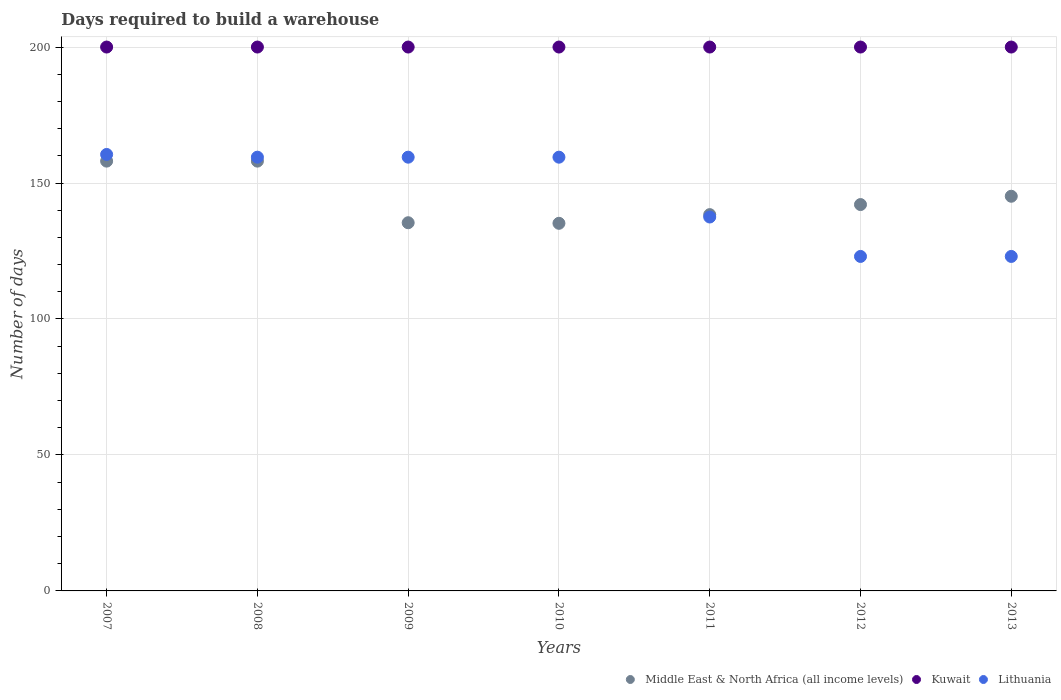How many different coloured dotlines are there?
Your answer should be compact. 3. Is the number of dotlines equal to the number of legend labels?
Provide a short and direct response. Yes. What is the days required to build a warehouse in in Kuwait in 2007?
Offer a terse response. 200. Across all years, what is the maximum days required to build a warehouse in in Lithuania?
Offer a very short reply. 160.5. Across all years, what is the minimum days required to build a warehouse in in Middle East & North Africa (all income levels)?
Provide a succinct answer. 135.18. In which year was the days required to build a warehouse in in Lithuania minimum?
Make the answer very short. 2012. What is the total days required to build a warehouse in in Lithuania in the graph?
Offer a terse response. 1022.5. What is the difference between the days required to build a warehouse in in Middle East & North Africa (all income levels) in 2007 and that in 2010?
Offer a terse response. 22.87. What is the difference between the days required to build a warehouse in in Middle East & North Africa (all income levels) in 2010 and the days required to build a warehouse in in Kuwait in 2009?
Your answer should be very brief. -64.82. What is the average days required to build a warehouse in in Lithuania per year?
Give a very brief answer. 146.07. In the year 2008, what is the difference between the days required to build a warehouse in in Kuwait and days required to build a warehouse in in Lithuania?
Ensure brevity in your answer.  40.5. In how many years, is the days required to build a warehouse in in Lithuania greater than 90 days?
Offer a terse response. 7. What is the ratio of the days required to build a warehouse in in Middle East & North Africa (all income levels) in 2008 to that in 2012?
Provide a succinct answer. 1.11. Is the days required to build a warehouse in in Kuwait in 2007 less than that in 2013?
Provide a succinct answer. No. Is the difference between the days required to build a warehouse in in Kuwait in 2010 and 2012 greater than the difference between the days required to build a warehouse in in Lithuania in 2010 and 2012?
Provide a succinct answer. No. What is the difference between the highest and the lowest days required to build a warehouse in in Lithuania?
Your answer should be compact. 37.5. In how many years, is the days required to build a warehouse in in Middle East & North Africa (all income levels) greater than the average days required to build a warehouse in in Middle East & North Africa (all income levels) taken over all years?
Your answer should be compact. 3. Is the sum of the days required to build a warehouse in in Kuwait in 2009 and 2013 greater than the maximum days required to build a warehouse in in Lithuania across all years?
Make the answer very short. Yes. Is it the case that in every year, the sum of the days required to build a warehouse in in Kuwait and days required to build a warehouse in in Middle East & North Africa (all income levels)  is greater than the days required to build a warehouse in in Lithuania?
Your answer should be compact. Yes. Does the days required to build a warehouse in in Kuwait monotonically increase over the years?
Offer a very short reply. No. Is the days required to build a warehouse in in Kuwait strictly greater than the days required to build a warehouse in in Lithuania over the years?
Provide a short and direct response. Yes. How many dotlines are there?
Ensure brevity in your answer.  3. What is the difference between two consecutive major ticks on the Y-axis?
Offer a very short reply. 50. Are the values on the major ticks of Y-axis written in scientific E-notation?
Make the answer very short. No. Does the graph contain grids?
Offer a very short reply. Yes. What is the title of the graph?
Make the answer very short. Days required to build a warehouse. What is the label or title of the X-axis?
Your answer should be compact. Years. What is the label or title of the Y-axis?
Your answer should be compact. Number of days. What is the Number of days of Middle East & North Africa (all income levels) in 2007?
Your response must be concise. 158.05. What is the Number of days of Kuwait in 2007?
Offer a terse response. 200. What is the Number of days in Lithuania in 2007?
Ensure brevity in your answer.  160.5. What is the Number of days of Middle East & North Africa (all income levels) in 2008?
Your response must be concise. 158.05. What is the Number of days of Kuwait in 2008?
Give a very brief answer. 200. What is the Number of days of Lithuania in 2008?
Offer a very short reply. 159.5. What is the Number of days of Middle East & North Africa (all income levels) in 2009?
Provide a succinct answer. 135.39. What is the Number of days of Lithuania in 2009?
Ensure brevity in your answer.  159.5. What is the Number of days of Middle East & North Africa (all income levels) in 2010?
Your response must be concise. 135.18. What is the Number of days in Lithuania in 2010?
Provide a short and direct response. 159.5. What is the Number of days in Middle East & North Africa (all income levels) in 2011?
Your answer should be compact. 138.38. What is the Number of days of Lithuania in 2011?
Offer a terse response. 137.5. What is the Number of days of Middle East & North Africa (all income levels) in 2012?
Your answer should be very brief. 142.07. What is the Number of days in Kuwait in 2012?
Offer a very short reply. 200. What is the Number of days of Lithuania in 2012?
Your response must be concise. 123. What is the Number of days in Middle East & North Africa (all income levels) in 2013?
Ensure brevity in your answer.  145.13. What is the Number of days of Lithuania in 2013?
Offer a terse response. 123. Across all years, what is the maximum Number of days in Middle East & North Africa (all income levels)?
Your answer should be compact. 158.05. Across all years, what is the maximum Number of days of Lithuania?
Your answer should be compact. 160.5. Across all years, what is the minimum Number of days of Middle East & North Africa (all income levels)?
Give a very brief answer. 135.18. Across all years, what is the minimum Number of days of Kuwait?
Provide a short and direct response. 200. Across all years, what is the minimum Number of days of Lithuania?
Your answer should be very brief. 123. What is the total Number of days in Middle East & North Africa (all income levels) in the graph?
Your response must be concise. 1012.27. What is the total Number of days in Kuwait in the graph?
Offer a terse response. 1400. What is the total Number of days in Lithuania in the graph?
Provide a short and direct response. 1022.5. What is the difference between the Number of days of Kuwait in 2007 and that in 2008?
Provide a short and direct response. 0. What is the difference between the Number of days of Middle East & North Africa (all income levels) in 2007 and that in 2009?
Your answer should be very brief. 22.66. What is the difference between the Number of days of Kuwait in 2007 and that in 2009?
Provide a succinct answer. 0. What is the difference between the Number of days of Lithuania in 2007 and that in 2009?
Keep it short and to the point. 1. What is the difference between the Number of days of Middle East & North Africa (all income levels) in 2007 and that in 2010?
Your answer should be compact. 22.87. What is the difference between the Number of days of Kuwait in 2007 and that in 2010?
Ensure brevity in your answer.  0. What is the difference between the Number of days in Lithuania in 2007 and that in 2010?
Your response must be concise. 1. What is the difference between the Number of days in Middle East & North Africa (all income levels) in 2007 and that in 2011?
Provide a short and direct response. 19.68. What is the difference between the Number of days of Kuwait in 2007 and that in 2011?
Your response must be concise. 0. What is the difference between the Number of days in Lithuania in 2007 and that in 2011?
Make the answer very short. 23. What is the difference between the Number of days in Middle East & North Africa (all income levels) in 2007 and that in 2012?
Ensure brevity in your answer.  15.98. What is the difference between the Number of days of Kuwait in 2007 and that in 2012?
Give a very brief answer. 0. What is the difference between the Number of days in Lithuania in 2007 and that in 2012?
Your answer should be very brief. 37.5. What is the difference between the Number of days in Middle East & North Africa (all income levels) in 2007 and that in 2013?
Your response must be concise. 12.92. What is the difference between the Number of days in Kuwait in 2007 and that in 2013?
Your response must be concise. 0. What is the difference between the Number of days in Lithuania in 2007 and that in 2013?
Keep it short and to the point. 37.5. What is the difference between the Number of days of Middle East & North Africa (all income levels) in 2008 and that in 2009?
Keep it short and to the point. 22.66. What is the difference between the Number of days in Kuwait in 2008 and that in 2009?
Your response must be concise. 0. What is the difference between the Number of days of Middle East & North Africa (all income levels) in 2008 and that in 2010?
Your answer should be compact. 22.87. What is the difference between the Number of days of Lithuania in 2008 and that in 2010?
Offer a very short reply. 0. What is the difference between the Number of days of Middle East & North Africa (all income levels) in 2008 and that in 2011?
Provide a succinct answer. 19.68. What is the difference between the Number of days in Middle East & North Africa (all income levels) in 2008 and that in 2012?
Keep it short and to the point. 15.98. What is the difference between the Number of days of Kuwait in 2008 and that in 2012?
Give a very brief answer. 0. What is the difference between the Number of days in Lithuania in 2008 and that in 2012?
Provide a succinct answer. 36.5. What is the difference between the Number of days in Middle East & North Africa (all income levels) in 2008 and that in 2013?
Ensure brevity in your answer.  12.92. What is the difference between the Number of days of Kuwait in 2008 and that in 2013?
Provide a succinct answer. 0. What is the difference between the Number of days of Lithuania in 2008 and that in 2013?
Offer a terse response. 36.5. What is the difference between the Number of days in Middle East & North Africa (all income levels) in 2009 and that in 2010?
Provide a short and direct response. 0.21. What is the difference between the Number of days in Kuwait in 2009 and that in 2010?
Make the answer very short. 0. What is the difference between the Number of days of Middle East & North Africa (all income levels) in 2009 and that in 2011?
Offer a terse response. -2.98. What is the difference between the Number of days in Kuwait in 2009 and that in 2011?
Your answer should be very brief. 0. What is the difference between the Number of days of Middle East & North Africa (all income levels) in 2009 and that in 2012?
Provide a short and direct response. -6.68. What is the difference between the Number of days in Kuwait in 2009 and that in 2012?
Your answer should be very brief. 0. What is the difference between the Number of days in Lithuania in 2009 and that in 2012?
Your answer should be very brief. 36.5. What is the difference between the Number of days of Middle East & North Africa (all income levels) in 2009 and that in 2013?
Provide a succinct answer. -9.74. What is the difference between the Number of days of Kuwait in 2009 and that in 2013?
Your answer should be compact. 0. What is the difference between the Number of days in Lithuania in 2009 and that in 2013?
Your answer should be compact. 36.5. What is the difference between the Number of days in Middle East & North Africa (all income levels) in 2010 and that in 2011?
Keep it short and to the point. -3.19. What is the difference between the Number of days of Lithuania in 2010 and that in 2011?
Give a very brief answer. 22. What is the difference between the Number of days in Middle East & North Africa (all income levels) in 2010 and that in 2012?
Make the answer very short. -6.89. What is the difference between the Number of days of Lithuania in 2010 and that in 2012?
Make the answer very short. 36.5. What is the difference between the Number of days in Middle East & North Africa (all income levels) in 2010 and that in 2013?
Your response must be concise. -9.95. What is the difference between the Number of days of Lithuania in 2010 and that in 2013?
Make the answer very short. 36.5. What is the difference between the Number of days of Middle East & North Africa (all income levels) in 2011 and that in 2012?
Provide a short and direct response. -3.7. What is the difference between the Number of days of Kuwait in 2011 and that in 2012?
Offer a terse response. 0. What is the difference between the Number of days in Middle East & North Africa (all income levels) in 2011 and that in 2013?
Offer a very short reply. -6.76. What is the difference between the Number of days in Lithuania in 2011 and that in 2013?
Offer a very short reply. 14.5. What is the difference between the Number of days of Middle East & North Africa (all income levels) in 2012 and that in 2013?
Make the answer very short. -3.06. What is the difference between the Number of days in Kuwait in 2012 and that in 2013?
Your response must be concise. 0. What is the difference between the Number of days of Lithuania in 2012 and that in 2013?
Provide a succinct answer. 0. What is the difference between the Number of days in Middle East & North Africa (all income levels) in 2007 and the Number of days in Kuwait in 2008?
Your answer should be very brief. -41.95. What is the difference between the Number of days in Middle East & North Africa (all income levels) in 2007 and the Number of days in Lithuania in 2008?
Your answer should be very brief. -1.45. What is the difference between the Number of days of Kuwait in 2007 and the Number of days of Lithuania in 2008?
Give a very brief answer. 40.5. What is the difference between the Number of days in Middle East & North Africa (all income levels) in 2007 and the Number of days in Kuwait in 2009?
Your response must be concise. -41.95. What is the difference between the Number of days of Middle East & North Africa (all income levels) in 2007 and the Number of days of Lithuania in 2009?
Your answer should be compact. -1.45. What is the difference between the Number of days of Kuwait in 2007 and the Number of days of Lithuania in 2009?
Ensure brevity in your answer.  40.5. What is the difference between the Number of days of Middle East & North Africa (all income levels) in 2007 and the Number of days of Kuwait in 2010?
Provide a succinct answer. -41.95. What is the difference between the Number of days of Middle East & North Africa (all income levels) in 2007 and the Number of days of Lithuania in 2010?
Your answer should be very brief. -1.45. What is the difference between the Number of days of Kuwait in 2007 and the Number of days of Lithuania in 2010?
Provide a succinct answer. 40.5. What is the difference between the Number of days of Middle East & North Africa (all income levels) in 2007 and the Number of days of Kuwait in 2011?
Provide a short and direct response. -41.95. What is the difference between the Number of days in Middle East & North Africa (all income levels) in 2007 and the Number of days in Lithuania in 2011?
Offer a very short reply. 20.55. What is the difference between the Number of days in Kuwait in 2007 and the Number of days in Lithuania in 2011?
Offer a terse response. 62.5. What is the difference between the Number of days in Middle East & North Africa (all income levels) in 2007 and the Number of days in Kuwait in 2012?
Your response must be concise. -41.95. What is the difference between the Number of days of Middle East & North Africa (all income levels) in 2007 and the Number of days of Lithuania in 2012?
Your answer should be very brief. 35.05. What is the difference between the Number of days in Middle East & North Africa (all income levels) in 2007 and the Number of days in Kuwait in 2013?
Offer a terse response. -41.95. What is the difference between the Number of days in Middle East & North Africa (all income levels) in 2007 and the Number of days in Lithuania in 2013?
Give a very brief answer. 35.05. What is the difference between the Number of days of Middle East & North Africa (all income levels) in 2008 and the Number of days of Kuwait in 2009?
Provide a short and direct response. -41.95. What is the difference between the Number of days of Middle East & North Africa (all income levels) in 2008 and the Number of days of Lithuania in 2009?
Make the answer very short. -1.45. What is the difference between the Number of days of Kuwait in 2008 and the Number of days of Lithuania in 2009?
Offer a terse response. 40.5. What is the difference between the Number of days in Middle East & North Africa (all income levels) in 2008 and the Number of days in Kuwait in 2010?
Offer a terse response. -41.95. What is the difference between the Number of days in Middle East & North Africa (all income levels) in 2008 and the Number of days in Lithuania in 2010?
Your answer should be compact. -1.45. What is the difference between the Number of days of Kuwait in 2008 and the Number of days of Lithuania in 2010?
Your answer should be very brief. 40.5. What is the difference between the Number of days in Middle East & North Africa (all income levels) in 2008 and the Number of days in Kuwait in 2011?
Give a very brief answer. -41.95. What is the difference between the Number of days of Middle East & North Africa (all income levels) in 2008 and the Number of days of Lithuania in 2011?
Keep it short and to the point. 20.55. What is the difference between the Number of days in Kuwait in 2008 and the Number of days in Lithuania in 2011?
Offer a very short reply. 62.5. What is the difference between the Number of days of Middle East & North Africa (all income levels) in 2008 and the Number of days of Kuwait in 2012?
Make the answer very short. -41.95. What is the difference between the Number of days in Middle East & North Africa (all income levels) in 2008 and the Number of days in Lithuania in 2012?
Ensure brevity in your answer.  35.05. What is the difference between the Number of days in Middle East & North Africa (all income levels) in 2008 and the Number of days in Kuwait in 2013?
Your answer should be compact. -41.95. What is the difference between the Number of days of Middle East & North Africa (all income levels) in 2008 and the Number of days of Lithuania in 2013?
Offer a terse response. 35.05. What is the difference between the Number of days in Middle East & North Africa (all income levels) in 2009 and the Number of days in Kuwait in 2010?
Offer a very short reply. -64.61. What is the difference between the Number of days in Middle East & North Africa (all income levels) in 2009 and the Number of days in Lithuania in 2010?
Your response must be concise. -24.11. What is the difference between the Number of days of Kuwait in 2009 and the Number of days of Lithuania in 2010?
Give a very brief answer. 40.5. What is the difference between the Number of days of Middle East & North Africa (all income levels) in 2009 and the Number of days of Kuwait in 2011?
Keep it short and to the point. -64.61. What is the difference between the Number of days in Middle East & North Africa (all income levels) in 2009 and the Number of days in Lithuania in 2011?
Your response must be concise. -2.11. What is the difference between the Number of days of Kuwait in 2009 and the Number of days of Lithuania in 2011?
Offer a terse response. 62.5. What is the difference between the Number of days in Middle East & North Africa (all income levels) in 2009 and the Number of days in Kuwait in 2012?
Your answer should be very brief. -64.61. What is the difference between the Number of days in Middle East & North Africa (all income levels) in 2009 and the Number of days in Lithuania in 2012?
Offer a terse response. 12.39. What is the difference between the Number of days in Kuwait in 2009 and the Number of days in Lithuania in 2012?
Your answer should be very brief. 77. What is the difference between the Number of days of Middle East & North Africa (all income levels) in 2009 and the Number of days of Kuwait in 2013?
Make the answer very short. -64.61. What is the difference between the Number of days in Middle East & North Africa (all income levels) in 2009 and the Number of days in Lithuania in 2013?
Give a very brief answer. 12.39. What is the difference between the Number of days of Kuwait in 2009 and the Number of days of Lithuania in 2013?
Ensure brevity in your answer.  77. What is the difference between the Number of days in Middle East & North Africa (all income levels) in 2010 and the Number of days in Kuwait in 2011?
Offer a very short reply. -64.82. What is the difference between the Number of days of Middle East & North Africa (all income levels) in 2010 and the Number of days of Lithuania in 2011?
Your answer should be very brief. -2.32. What is the difference between the Number of days of Kuwait in 2010 and the Number of days of Lithuania in 2011?
Your answer should be compact. 62.5. What is the difference between the Number of days of Middle East & North Africa (all income levels) in 2010 and the Number of days of Kuwait in 2012?
Make the answer very short. -64.82. What is the difference between the Number of days in Middle East & North Africa (all income levels) in 2010 and the Number of days in Lithuania in 2012?
Give a very brief answer. 12.18. What is the difference between the Number of days in Kuwait in 2010 and the Number of days in Lithuania in 2012?
Provide a succinct answer. 77. What is the difference between the Number of days in Middle East & North Africa (all income levels) in 2010 and the Number of days in Kuwait in 2013?
Ensure brevity in your answer.  -64.82. What is the difference between the Number of days in Middle East & North Africa (all income levels) in 2010 and the Number of days in Lithuania in 2013?
Offer a terse response. 12.18. What is the difference between the Number of days of Middle East & North Africa (all income levels) in 2011 and the Number of days of Kuwait in 2012?
Offer a terse response. -61.62. What is the difference between the Number of days in Middle East & North Africa (all income levels) in 2011 and the Number of days in Lithuania in 2012?
Keep it short and to the point. 15.38. What is the difference between the Number of days in Kuwait in 2011 and the Number of days in Lithuania in 2012?
Make the answer very short. 77. What is the difference between the Number of days of Middle East & North Africa (all income levels) in 2011 and the Number of days of Kuwait in 2013?
Make the answer very short. -61.62. What is the difference between the Number of days of Middle East & North Africa (all income levels) in 2011 and the Number of days of Lithuania in 2013?
Make the answer very short. 15.38. What is the difference between the Number of days of Middle East & North Africa (all income levels) in 2012 and the Number of days of Kuwait in 2013?
Provide a succinct answer. -57.92. What is the difference between the Number of days in Middle East & North Africa (all income levels) in 2012 and the Number of days in Lithuania in 2013?
Provide a succinct answer. 19.07. What is the average Number of days in Middle East & North Africa (all income levels) per year?
Offer a very short reply. 144.61. What is the average Number of days in Kuwait per year?
Your response must be concise. 200. What is the average Number of days of Lithuania per year?
Your answer should be very brief. 146.07. In the year 2007, what is the difference between the Number of days in Middle East & North Africa (all income levels) and Number of days in Kuwait?
Provide a short and direct response. -41.95. In the year 2007, what is the difference between the Number of days in Middle East & North Africa (all income levels) and Number of days in Lithuania?
Provide a short and direct response. -2.45. In the year 2007, what is the difference between the Number of days of Kuwait and Number of days of Lithuania?
Your response must be concise. 39.5. In the year 2008, what is the difference between the Number of days in Middle East & North Africa (all income levels) and Number of days in Kuwait?
Your answer should be very brief. -41.95. In the year 2008, what is the difference between the Number of days in Middle East & North Africa (all income levels) and Number of days in Lithuania?
Your response must be concise. -1.45. In the year 2008, what is the difference between the Number of days in Kuwait and Number of days in Lithuania?
Offer a very short reply. 40.5. In the year 2009, what is the difference between the Number of days of Middle East & North Africa (all income levels) and Number of days of Kuwait?
Provide a short and direct response. -64.61. In the year 2009, what is the difference between the Number of days in Middle East & North Africa (all income levels) and Number of days in Lithuania?
Provide a short and direct response. -24.11. In the year 2009, what is the difference between the Number of days of Kuwait and Number of days of Lithuania?
Make the answer very short. 40.5. In the year 2010, what is the difference between the Number of days in Middle East & North Africa (all income levels) and Number of days in Kuwait?
Give a very brief answer. -64.82. In the year 2010, what is the difference between the Number of days of Middle East & North Africa (all income levels) and Number of days of Lithuania?
Make the answer very short. -24.32. In the year 2010, what is the difference between the Number of days of Kuwait and Number of days of Lithuania?
Provide a succinct answer. 40.5. In the year 2011, what is the difference between the Number of days in Middle East & North Africa (all income levels) and Number of days in Kuwait?
Ensure brevity in your answer.  -61.62. In the year 2011, what is the difference between the Number of days in Middle East & North Africa (all income levels) and Number of days in Lithuania?
Your answer should be compact. 0.88. In the year 2011, what is the difference between the Number of days in Kuwait and Number of days in Lithuania?
Your response must be concise. 62.5. In the year 2012, what is the difference between the Number of days in Middle East & North Africa (all income levels) and Number of days in Kuwait?
Provide a short and direct response. -57.92. In the year 2012, what is the difference between the Number of days in Middle East & North Africa (all income levels) and Number of days in Lithuania?
Provide a succinct answer. 19.07. In the year 2013, what is the difference between the Number of days of Middle East & North Africa (all income levels) and Number of days of Kuwait?
Offer a very short reply. -54.87. In the year 2013, what is the difference between the Number of days in Middle East & North Africa (all income levels) and Number of days in Lithuania?
Your response must be concise. 22.13. What is the ratio of the Number of days in Middle East & North Africa (all income levels) in 2007 to that in 2008?
Keep it short and to the point. 1. What is the ratio of the Number of days in Middle East & North Africa (all income levels) in 2007 to that in 2009?
Provide a short and direct response. 1.17. What is the ratio of the Number of days of Kuwait in 2007 to that in 2009?
Give a very brief answer. 1. What is the ratio of the Number of days of Middle East & North Africa (all income levels) in 2007 to that in 2010?
Offer a terse response. 1.17. What is the ratio of the Number of days in Lithuania in 2007 to that in 2010?
Ensure brevity in your answer.  1.01. What is the ratio of the Number of days in Middle East & North Africa (all income levels) in 2007 to that in 2011?
Keep it short and to the point. 1.14. What is the ratio of the Number of days of Lithuania in 2007 to that in 2011?
Provide a short and direct response. 1.17. What is the ratio of the Number of days of Middle East & North Africa (all income levels) in 2007 to that in 2012?
Your answer should be compact. 1.11. What is the ratio of the Number of days in Kuwait in 2007 to that in 2012?
Provide a succinct answer. 1. What is the ratio of the Number of days of Lithuania in 2007 to that in 2012?
Offer a terse response. 1.3. What is the ratio of the Number of days of Middle East & North Africa (all income levels) in 2007 to that in 2013?
Provide a short and direct response. 1.09. What is the ratio of the Number of days in Kuwait in 2007 to that in 2013?
Offer a terse response. 1. What is the ratio of the Number of days of Lithuania in 2007 to that in 2013?
Your response must be concise. 1.3. What is the ratio of the Number of days in Middle East & North Africa (all income levels) in 2008 to that in 2009?
Keep it short and to the point. 1.17. What is the ratio of the Number of days in Lithuania in 2008 to that in 2009?
Make the answer very short. 1. What is the ratio of the Number of days of Middle East & North Africa (all income levels) in 2008 to that in 2010?
Make the answer very short. 1.17. What is the ratio of the Number of days in Kuwait in 2008 to that in 2010?
Make the answer very short. 1. What is the ratio of the Number of days in Middle East & North Africa (all income levels) in 2008 to that in 2011?
Ensure brevity in your answer.  1.14. What is the ratio of the Number of days in Kuwait in 2008 to that in 2011?
Your answer should be compact. 1. What is the ratio of the Number of days of Lithuania in 2008 to that in 2011?
Your response must be concise. 1.16. What is the ratio of the Number of days of Middle East & North Africa (all income levels) in 2008 to that in 2012?
Your answer should be very brief. 1.11. What is the ratio of the Number of days of Lithuania in 2008 to that in 2012?
Provide a succinct answer. 1.3. What is the ratio of the Number of days of Middle East & North Africa (all income levels) in 2008 to that in 2013?
Offer a terse response. 1.09. What is the ratio of the Number of days in Kuwait in 2008 to that in 2013?
Keep it short and to the point. 1. What is the ratio of the Number of days in Lithuania in 2008 to that in 2013?
Offer a terse response. 1.3. What is the ratio of the Number of days in Middle East & North Africa (all income levels) in 2009 to that in 2010?
Your answer should be very brief. 1. What is the ratio of the Number of days of Kuwait in 2009 to that in 2010?
Your answer should be compact. 1. What is the ratio of the Number of days in Lithuania in 2009 to that in 2010?
Ensure brevity in your answer.  1. What is the ratio of the Number of days in Middle East & North Africa (all income levels) in 2009 to that in 2011?
Offer a very short reply. 0.98. What is the ratio of the Number of days of Kuwait in 2009 to that in 2011?
Provide a short and direct response. 1. What is the ratio of the Number of days in Lithuania in 2009 to that in 2011?
Provide a short and direct response. 1.16. What is the ratio of the Number of days of Middle East & North Africa (all income levels) in 2009 to that in 2012?
Ensure brevity in your answer.  0.95. What is the ratio of the Number of days of Lithuania in 2009 to that in 2012?
Provide a succinct answer. 1.3. What is the ratio of the Number of days in Middle East & North Africa (all income levels) in 2009 to that in 2013?
Keep it short and to the point. 0.93. What is the ratio of the Number of days in Lithuania in 2009 to that in 2013?
Your answer should be very brief. 1.3. What is the ratio of the Number of days of Middle East & North Africa (all income levels) in 2010 to that in 2011?
Give a very brief answer. 0.98. What is the ratio of the Number of days in Kuwait in 2010 to that in 2011?
Give a very brief answer. 1. What is the ratio of the Number of days of Lithuania in 2010 to that in 2011?
Your answer should be very brief. 1.16. What is the ratio of the Number of days of Middle East & North Africa (all income levels) in 2010 to that in 2012?
Keep it short and to the point. 0.95. What is the ratio of the Number of days of Lithuania in 2010 to that in 2012?
Your response must be concise. 1.3. What is the ratio of the Number of days of Middle East & North Africa (all income levels) in 2010 to that in 2013?
Your response must be concise. 0.93. What is the ratio of the Number of days in Lithuania in 2010 to that in 2013?
Your answer should be compact. 1.3. What is the ratio of the Number of days of Middle East & North Africa (all income levels) in 2011 to that in 2012?
Offer a very short reply. 0.97. What is the ratio of the Number of days of Kuwait in 2011 to that in 2012?
Your answer should be compact. 1. What is the ratio of the Number of days in Lithuania in 2011 to that in 2012?
Provide a short and direct response. 1.12. What is the ratio of the Number of days in Middle East & North Africa (all income levels) in 2011 to that in 2013?
Offer a terse response. 0.95. What is the ratio of the Number of days in Kuwait in 2011 to that in 2013?
Your answer should be very brief. 1. What is the ratio of the Number of days of Lithuania in 2011 to that in 2013?
Your answer should be compact. 1.12. What is the ratio of the Number of days of Middle East & North Africa (all income levels) in 2012 to that in 2013?
Offer a very short reply. 0.98. What is the ratio of the Number of days in Kuwait in 2012 to that in 2013?
Your answer should be compact. 1. What is the ratio of the Number of days of Lithuania in 2012 to that in 2013?
Give a very brief answer. 1. What is the difference between the highest and the second highest Number of days of Kuwait?
Your answer should be compact. 0. What is the difference between the highest and the second highest Number of days in Lithuania?
Give a very brief answer. 1. What is the difference between the highest and the lowest Number of days in Middle East & North Africa (all income levels)?
Make the answer very short. 22.87. What is the difference between the highest and the lowest Number of days of Lithuania?
Offer a terse response. 37.5. 